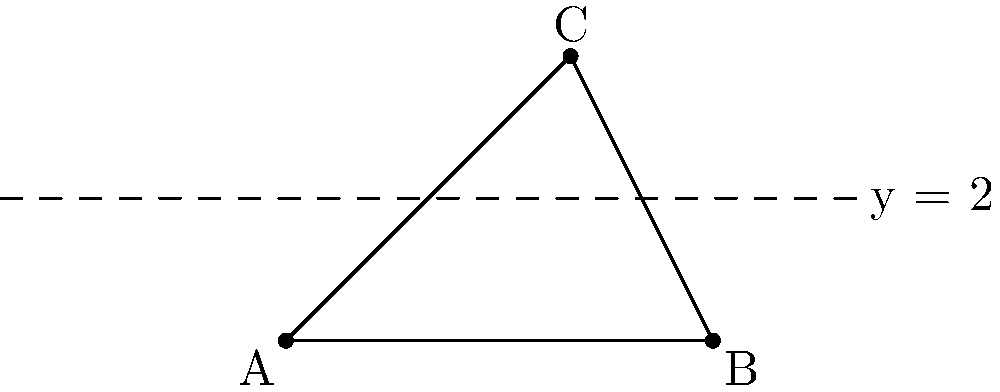In the NBN HFC network design, a triangular coverage area is represented by triangle ABC with coordinates A(1,1), B(4,1), and C(3,3). To optimize signal distribution, you need to reflect this triangle across the line y = 2. What are the coordinates of the reflected triangle A'B'C'? To reflect the triangle across the line y = 2, we need to follow these steps:

1) The reflection formula across a horizontal line y = k is (x, y) → (x, 2k - y).

2) For each point, we apply the formula with k = 2:

   For A(1,1):
   x' = 1
   y' = 2(2) - 1 = 3
   A' = (1,3)

   For B(4,1):
   x' = 4
   y' = 2(2) - 1 = 3
   B' = (4,3)

   For C(3,3):
   x' = 3
   y' = 2(2) - 3 = 1
   C' = (3,1)

3) Therefore, the coordinates of the reflected triangle A'B'C' are:
   A'(1,3), B'(4,3), C'(3,1)
Answer: A'(1,3), B'(4,3), C'(3,1) 